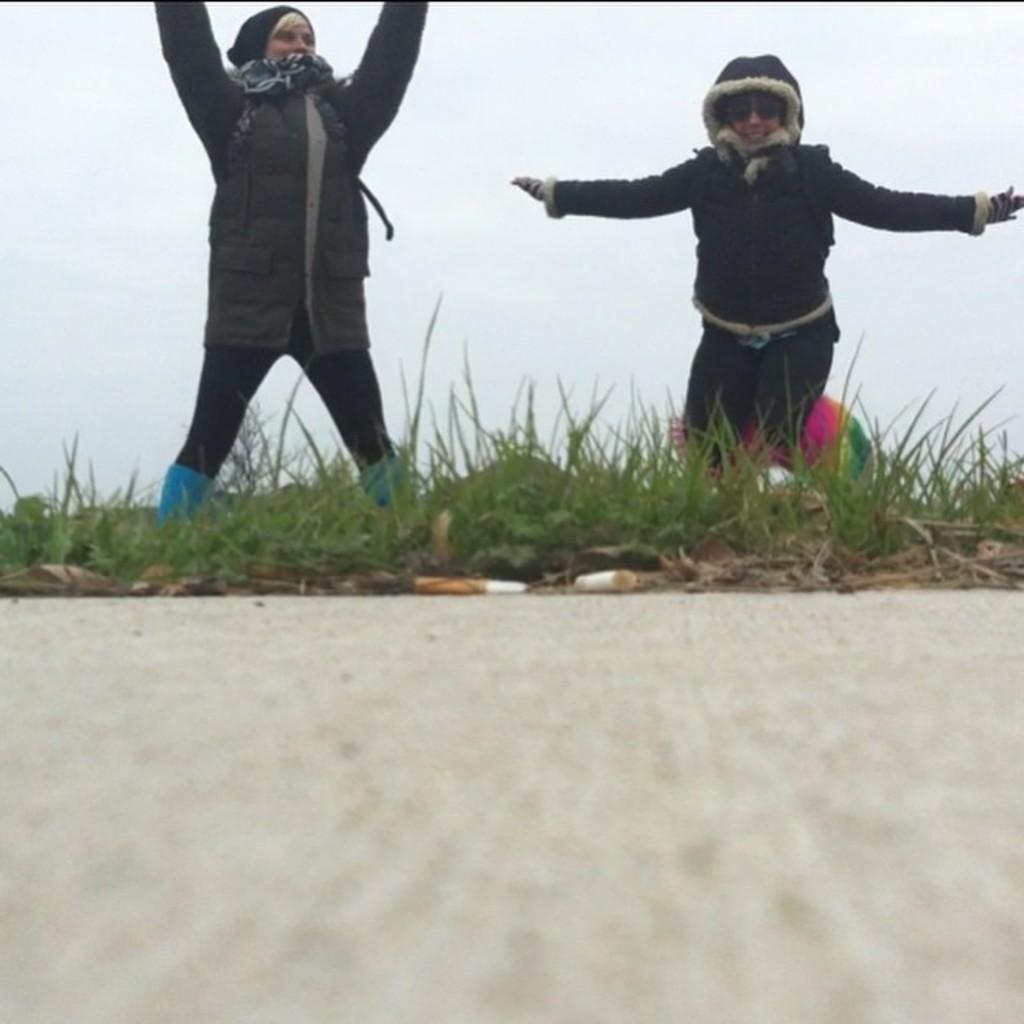Who is present in the image? There are girls in the image. Where are the girls located in the image? The girls are in the center of the image. What type of environment is visible in the image? There is grassland in the center of the image. What is the taste of the crow in the image? There is no crow present in the image, so it is not possible to determine its taste. 